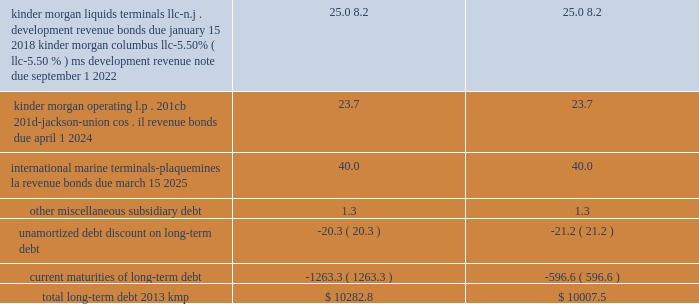Item 15 .
Exhibits , financial statement schedules .
( continued ) kinder morgan , inc .
Form 10-k .
____________ ( a ) as a result of the implementation of asu 2009-17 , effective january 1 , 2010 , we ( i ) include the transactions and balances of our business trust , k n capital trust i and k n capital trust iii , in our consolidated financial statements and ( ii ) no longer include our junior subordinated deferrable interest debentures issued to the capital trusts ( see note 18 201crecent accounting pronouncements 201d ) .
( b ) kmp issued its $ 500 million in principal amount of 9.00% ( 9.00 % ) senior notes due february 1 , 2019 in december 2008 .
Each holder of the notes has the right to require kmp to repurchase all or a portion of the notes owned by such holder on february 1 , 2012 at a purchase price equal to 100% ( 100 % ) of the principal amount of the notes tendered by the holder plus accrued and unpaid interest to , but excluding , the repurchase date .
On and after february 1 , 2012 , interest will cease to accrue on the notes tendered for repayment .
A holder 2019s exercise of the repurchase option is irrevocable .
Kinder morgan kansas , inc .
The 2028 and 2098 debentures and the 2012 and 2015 senior notes are redeemable in whole or in part , at kinder morgan kansas , inc . 2019s option at any time , at redemption prices defined in the associated prospectus supplements .
The 2027 debentures are redeemable in whole or in part , at kinder morgan kansas , inc . 2019s option after november 1 , 2004 at redemption prices defined in the associated prospectus supplements .
On september 2 , 2010 , kinder morgan kansas , inc .
Paid the remaining $ 1.1 million principal balance outstanding on kinder morgan kansas , inc . 2019s 6.50% ( 6.50 % ) series debentures , due 2013 .
Kinder morgan finance company , llc on december 20 , 2010 , kinder morgan finance company , llc , a wholly owned subsidiary of kinder morgan kansas , inc. , completed a public offering of senior notes .
It issued a total of $ 750 million in principal amount of 6.00% ( 6.00 % ) senior notes due january 15 , 2018 .
Net proceeds received from the issuance of the notes , after underwriting discounts and commissions , were $ 744.2 million , which were used to retire the principal amount of the 5.35% ( 5.35 % ) senior notes that matured on january 5 , 2011 .
The 2011 , 2016 , 2018 and 2036 senior notes issued by kinder morgan finance company , llc are redeemable in whole or in part , at kinder morgan kansas , inc . 2019s option at any time , at redemption prices defined in the associated prospectus supplements .
Each series of these notes is fully and unconditionally guaranteed by kinder morgan kansas , inc .
On a senior unsecured basis as to principal , interest and any additional amounts required to be paid as a result of any withholding or deduction for canadian taxes .
Capital trust securities kinder morgan kansas , inc . 2019s business trusts , k n capital trust i and k n capital trust iii , are obligated for $ 12.7 million of 8.56% ( 8.56 % ) capital trust securities maturing on april 15 , 2027 and $ 14.4 million of 7.63% ( 7.63 % ) capital trust securities maturing on april 15 , 2028 , respectively , which it guarantees .
The 2028 securities are redeemable in whole or in part , at kinder morgan kansas , inc . 2019s option at any time , at redemption prices as defined in the associated prospectus .
The 2027 securities are redeemable in whole or in part at kinder morgan kansas , inc . 2019s option and at any time in certain limited circumstances upon the occurrence of certain events and at prices , all defined in the associated prospectus supplements .
Upon redemption by kinder morgan kansas , inc .
Or at maturity of the junior subordinated deferrable interest debentures , it must use the proceeds to make redemptions of the capital trust securities on a pro rata basis. .
What is the value of unamortized debt discount on long-term debt as a percent of total long-term debt for the second column? 
Computations: ((21.2 / 10007.5) * 100%)
Answer: 0.00212. 